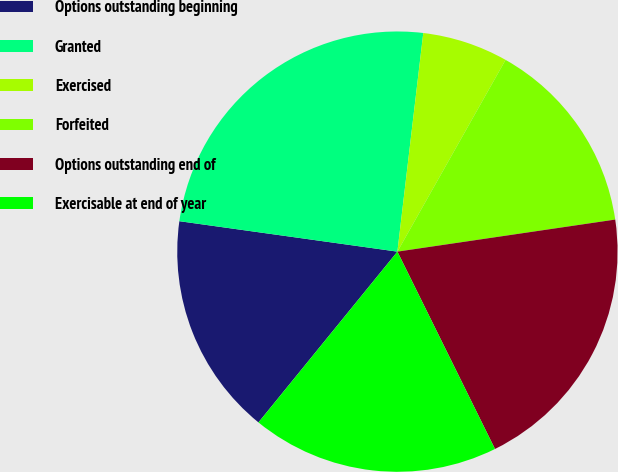Convert chart to OTSL. <chart><loc_0><loc_0><loc_500><loc_500><pie_chart><fcel>Options outstanding beginning<fcel>Granted<fcel>Exercised<fcel>Forfeited<fcel>Options outstanding end of<fcel>Exercisable at end of year<nl><fcel>16.34%<fcel>24.67%<fcel>6.3%<fcel>14.5%<fcel>20.02%<fcel>18.18%<nl></chart> 